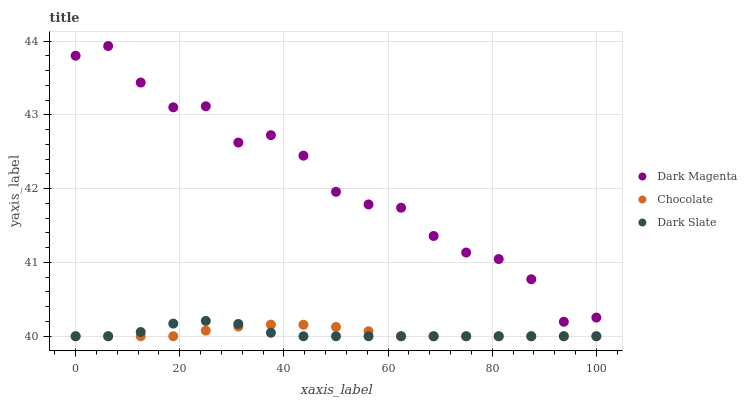Does Dark Slate have the minimum area under the curve?
Answer yes or no. Yes. Does Dark Magenta have the maximum area under the curve?
Answer yes or no. Yes. Does Chocolate have the minimum area under the curve?
Answer yes or no. No. Does Chocolate have the maximum area under the curve?
Answer yes or no. No. Is Chocolate the smoothest?
Answer yes or no. Yes. Is Dark Magenta the roughest?
Answer yes or no. Yes. Is Dark Magenta the smoothest?
Answer yes or no. No. Is Chocolate the roughest?
Answer yes or no. No. Does Dark Slate have the lowest value?
Answer yes or no. Yes. Does Dark Magenta have the lowest value?
Answer yes or no. No. Does Dark Magenta have the highest value?
Answer yes or no. Yes. Does Chocolate have the highest value?
Answer yes or no. No. Is Dark Slate less than Dark Magenta?
Answer yes or no. Yes. Is Dark Magenta greater than Chocolate?
Answer yes or no. Yes. Does Dark Slate intersect Chocolate?
Answer yes or no. Yes. Is Dark Slate less than Chocolate?
Answer yes or no. No. Is Dark Slate greater than Chocolate?
Answer yes or no. No. Does Dark Slate intersect Dark Magenta?
Answer yes or no. No. 